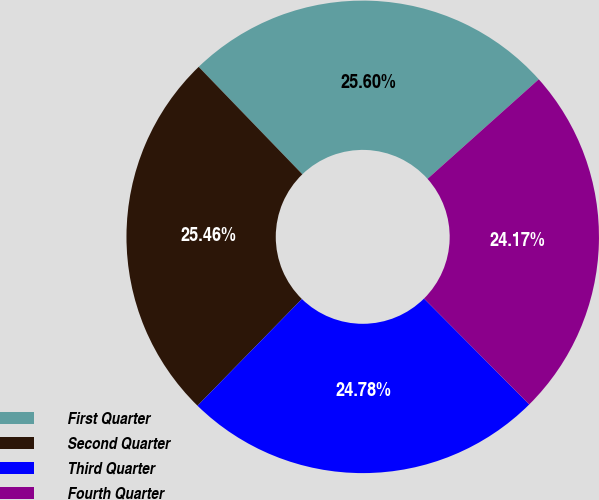<chart> <loc_0><loc_0><loc_500><loc_500><pie_chart><fcel>First Quarter<fcel>Second Quarter<fcel>Third Quarter<fcel>Fourth Quarter<nl><fcel>25.6%<fcel>25.46%<fcel>24.78%<fcel>24.17%<nl></chart> 